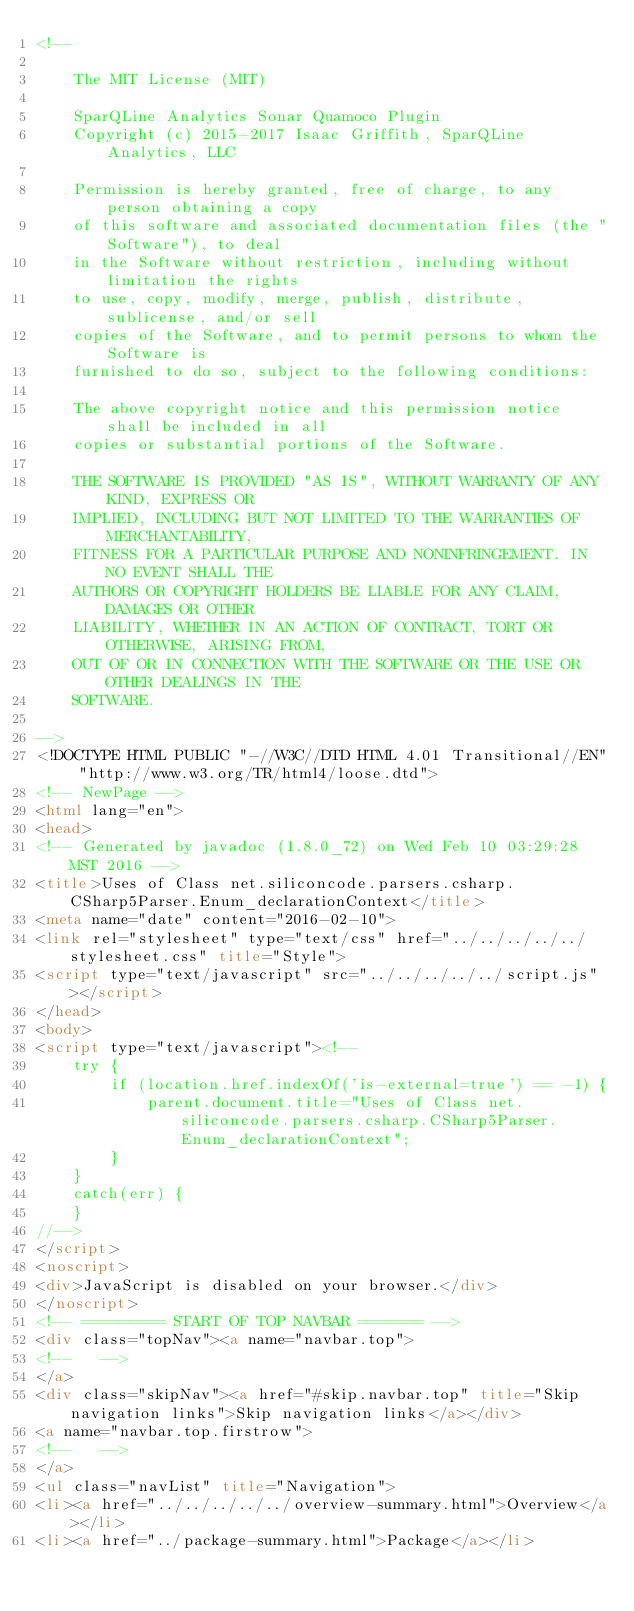Convert code to text. <code><loc_0><loc_0><loc_500><loc_500><_HTML_><!--

    The MIT License (MIT)

    SparQLine Analytics Sonar Quamoco Plugin
    Copyright (c) 2015-2017 Isaac Griffith, SparQLine Analytics, LLC

    Permission is hereby granted, free of charge, to any person obtaining a copy
    of this software and associated documentation files (the "Software"), to deal
    in the Software without restriction, including without limitation the rights
    to use, copy, modify, merge, publish, distribute, sublicense, and/or sell
    copies of the Software, and to permit persons to whom the Software is
    furnished to do so, subject to the following conditions:

    The above copyright notice and this permission notice shall be included in all
    copies or substantial portions of the Software.

    THE SOFTWARE IS PROVIDED "AS IS", WITHOUT WARRANTY OF ANY KIND, EXPRESS OR
    IMPLIED, INCLUDING BUT NOT LIMITED TO THE WARRANTIES OF MERCHANTABILITY,
    FITNESS FOR A PARTICULAR PURPOSE AND NONINFRINGEMENT. IN NO EVENT SHALL THE
    AUTHORS OR COPYRIGHT HOLDERS BE LIABLE FOR ANY CLAIM, DAMAGES OR OTHER
    LIABILITY, WHETHER IN AN ACTION OF CONTRACT, TORT OR OTHERWISE, ARISING FROM,
    OUT OF OR IN CONNECTION WITH THE SOFTWARE OR THE USE OR OTHER DEALINGS IN THE
    SOFTWARE.

-->
<!DOCTYPE HTML PUBLIC "-//W3C//DTD HTML 4.01 Transitional//EN" "http://www.w3.org/TR/html4/loose.dtd">
<!-- NewPage -->
<html lang="en">
<head>
<!-- Generated by javadoc (1.8.0_72) on Wed Feb 10 03:29:28 MST 2016 -->
<title>Uses of Class net.siliconcode.parsers.csharp.CSharp5Parser.Enum_declarationContext</title>
<meta name="date" content="2016-02-10">
<link rel="stylesheet" type="text/css" href="../../../../../stylesheet.css" title="Style">
<script type="text/javascript" src="../../../../../script.js"></script>
</head>
<body>
<script type="text/javascript"><!--
    try {
        if (location.href.indexOf('is-external=true') == -1) {
            parent.document.title="Uses of Class net.siliconcode.parsers.csharp.CSharp5Parser.Enum_declarationContext";
        }
    }
    catch(err) {
    }
//-->
</script>
<noscript>
<div>JavaScript is disabled on your browser.</div>
</noscript>
<!-- ========= START OF TOP NAVBAR ======= -->
<div class="topNav"><a name="navbar.top">
<!--   -->
</a>
<div class="skipNav"><a href="#skip.navbar.top" title="Skip navigation links">Skip navigation links</a></div>
<a name="navbar.top.firstrow">
<!--   -->
</a>
<ul class="navList" title="Navigation">
<li><a href="../../../../../overview-summary.html">Overview</a></li>
<li><a href="../package-summary.html">Package</a></li></code> 